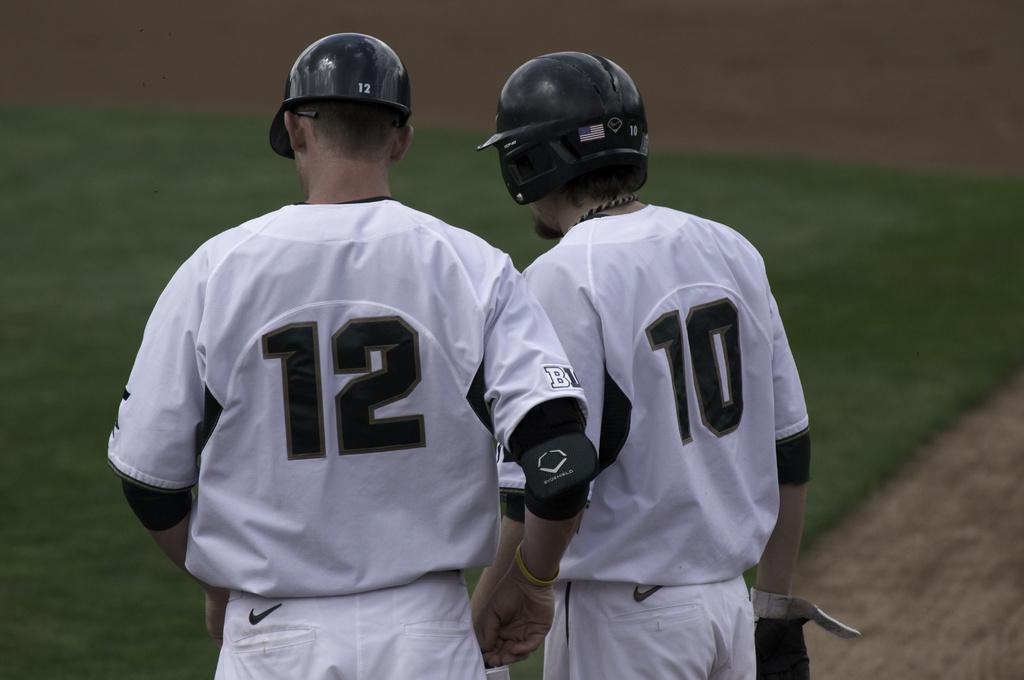How many people are in the image? There are two persons in the image. What are the persons wearing on their heads? Both persons are wearing helmets. What type of surface is visible in the image? There is grass visible in the image. Can you describe the background of the image? The background of the image is blurred. What type of coat is the person wearing in the image? There is no coat visible in the image; both persons are wearing helmets. Can you describe the kiss between the two persons in the image? There is no kiss depicted in the image; the persons are wearing helmets and no other interactions are shown. 